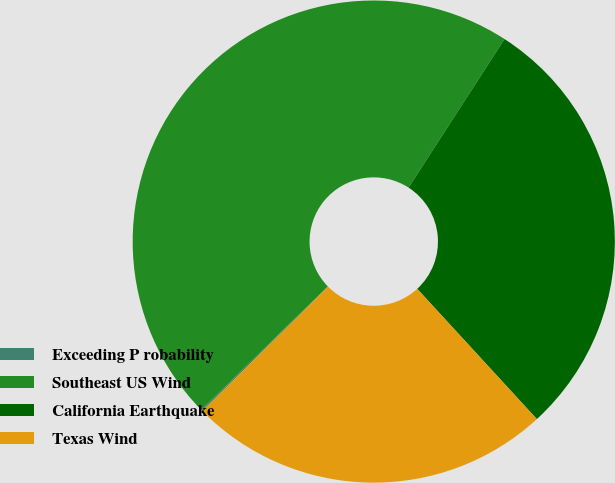Convert chart. <chart><loc_0><loc_0><loc_500><loc_500><pie_chart><fcel>Exceeding P robability<fcel>Southeast US Wind<fcel>California Earthquake<fcel>Texas Wind<nl><fcel>0.1%<fcel>46.43%<fcel>29.05%<fcel>24.42%<nl></chart> 